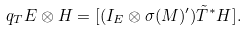<formula> <loc_0><loc_0><loc_500><loc_500>q _ { T } E \otimes H = [ ( I _ { E } \otimes \sigma ( M ) ^ { \prime } ) \tilde { T } ^ { \ast } H ] .</formula> 